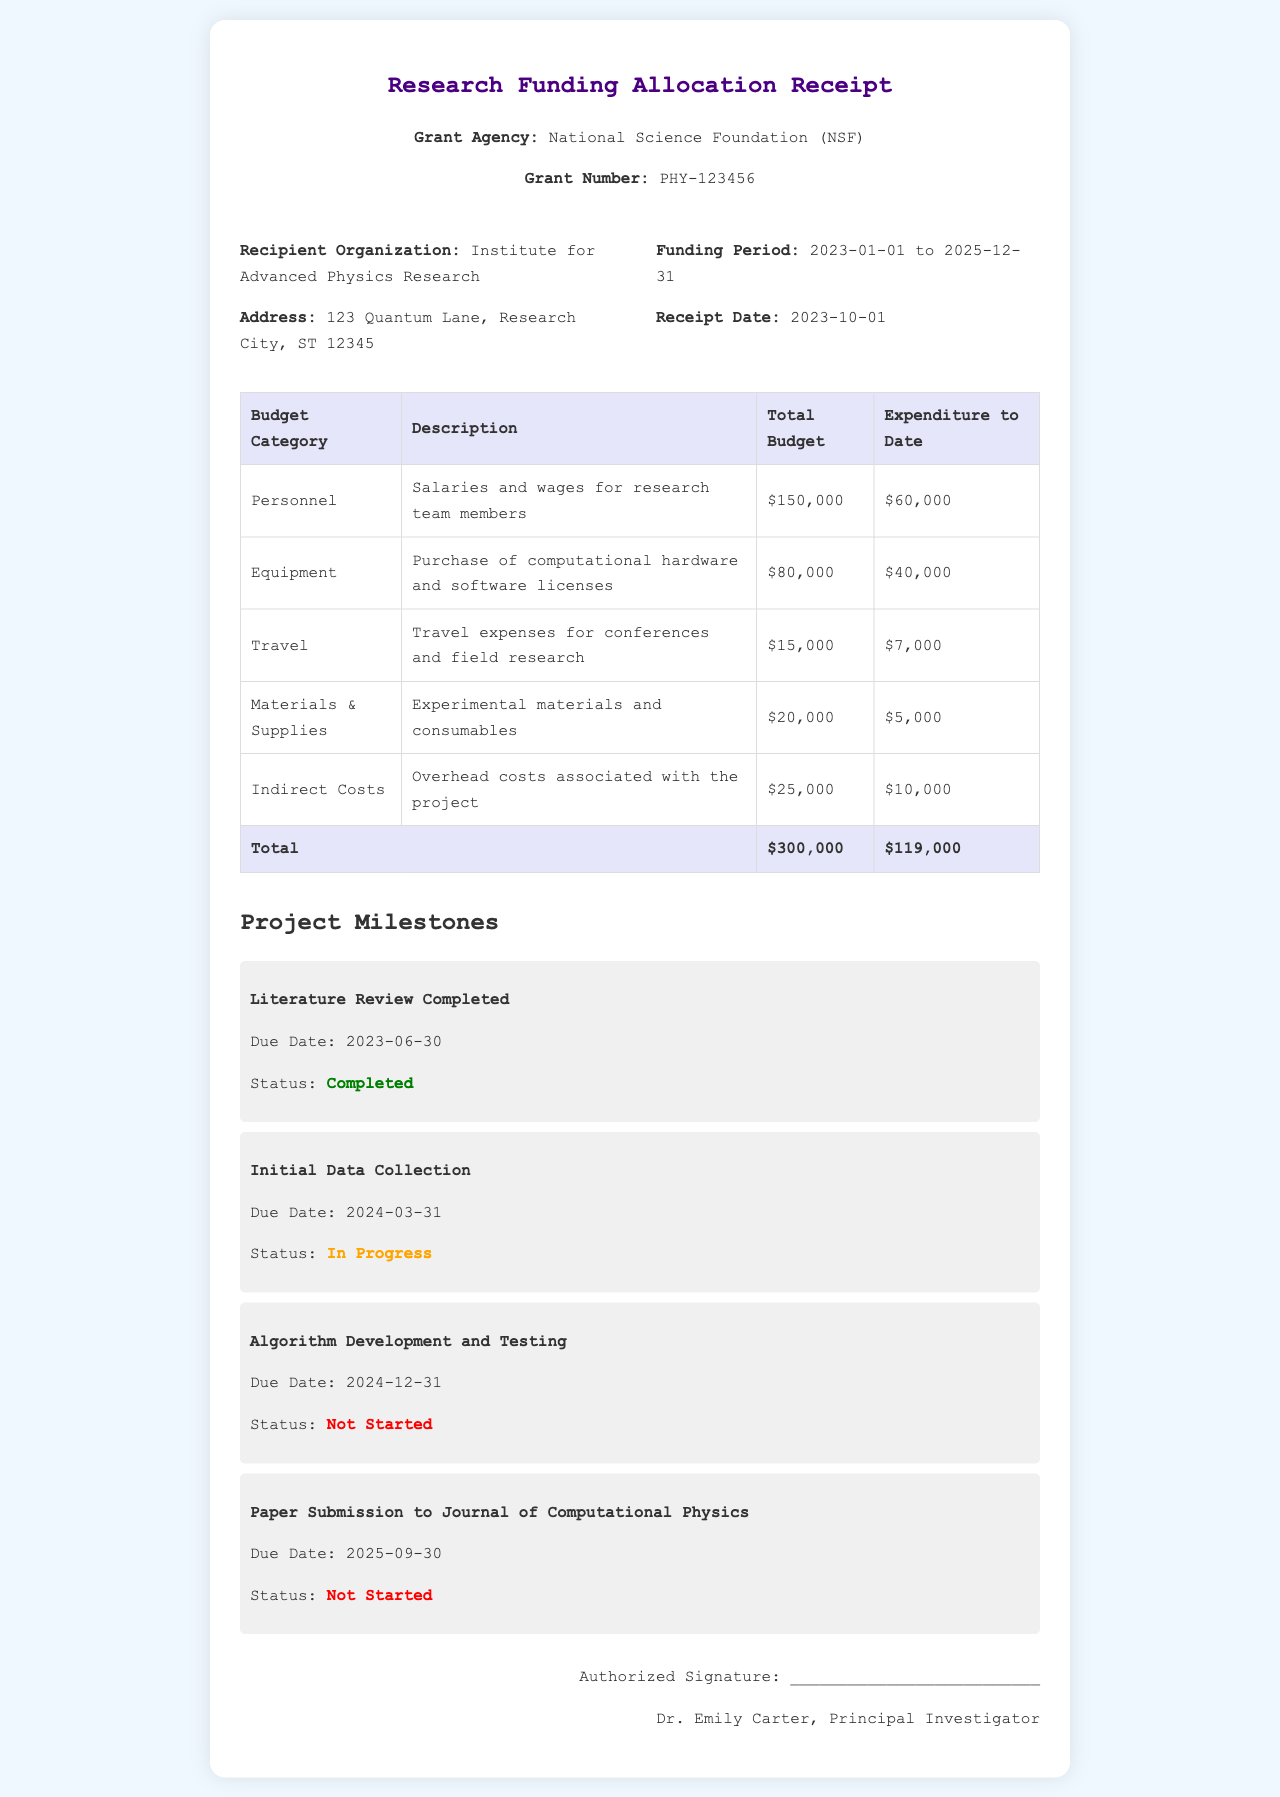What is the grant agency? The grant agency is listed at the top of the document, which states it is the National Science Foundation (NSF).
Answer: National Science Foundation (NSF) What is the grant number? The grant number is specified in the document, indicating its unique identifier for the project, which is PHY-123456.
Answer: PHY-123456 What is the total budget allocated for personnel? The document details the total budget for the personnel category, which is $150,000.
Answer: $150,000 What percentage of the total budget has been spent to date? By calculating the ratio of the total expenditure ($119,000) to the total budget ($300,000) and converting it into a percentage, we find the result.
Answer: 39.67% What is the status of the "Algorithm Development and Testing" milestone? The milestone section of the document lists the status of this specific milestone, which is marked as "Not Started."
Answer: Not Started When is the due date for paper submission? The due date for paper submission is mentioned in the milestones, listed as September 30, 2025.
Answer: 2025-09-30 How much has been spent on travel so far? The specific expenditure for travel is outlined in the budget section, which indicates that $7,000 has been spent.
Answer: $7,000 What is the total allocation for indirect costs? The document specifies the total budget allocated for indirect costs, which is $25,000.
Answer: $25,000 Who is the principal investigator? The document lists the principal investigator at the bottom, whose name is Dr. Emily Carter.
Answer: Dr. Emily Carter 